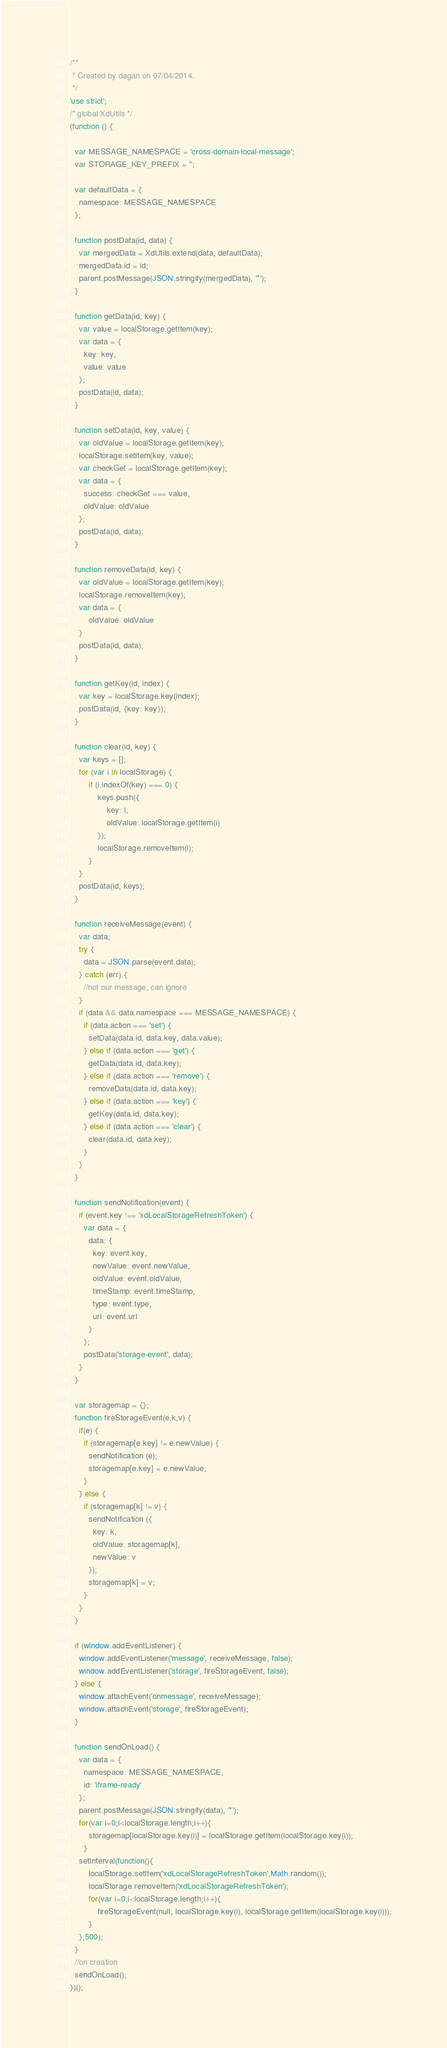<code> <loc_0><loc_0><loc_500><loc_500><_JavaScript_>/**
 * Created by dagan on 07/04/2014.
 */
'use strict';
/* global XdUtils */
(function () {

  var MESSAGE_NAMESPACE = 'cross-domain-local-message';
  var STORAGE_KEY_PREFIX = '';

  var defaultData = {
    namespace: MESSAGE_NAMESPACE
  };

  function postData(id, data) {
    var mergedData = XdUtils.extend(data, defaultData);
    mergedData.id = id;
    parent.postMessage(JSON.stringify(mergedData), '*');
  }

  function getData(id, key) {
    var value = localStorage.getItem(key);
    var data = {
      key: key,
      value: value
    };
    postData(id, data);
  }

  function setData(id, key, value) {
    var oldValue = localStorage.getItem(key);
    localStorage.setItem(key, value);
    var checkGet = localStorage.getItem(key);
    var data = {
      success: checkGet === value,
      oldValue: oldValue
    };
    postData(id, data);
  }

  function removeData(id, key) {
    var oldValue = localStorage.getItem(key);
    localStorage.removeItem(key);
    var data = {
        oldValue: oldValue
    }
    postData(id, data);
  }

  function getKey(id, index) {
    var key = localStorage.key(index);
    postData(id, {key: key});
  }

  function clear(id, key) {
    var keys = [];
    for (var i in localStorage) {
        if (i.indexOf(key) === 0) {
            keys.push({
                key: i,
                oldValue: localStorage.getItem(i)
            });
            localStorage.removeItem(i);
        }
    }
    postData(id, keys);
  }

  function receiveMessage(event) {
    var data;
    try {
      data = JSON.parse(event.data);
    } catch (err) {
      //not our message, can ignore
    }
    if (data && data.namespace === MESSAGE_NAMESPACE) {
      if (data.action === 'set') {
        setData(data.id, data.key, data.value);
      } else if (data.action === 'get') {
        getData(data.id, data.key);
      } else if (data.action === 'remove') {
        removeData(data.id, data.key);
      } else if (data.action === 'key') {
        getKey(data.id, data.key);
      } else if (data.action === 'clear') {
        clear(data.id, data.key);
      }
    }
  }

  function sendNotification(event) {
    if (event.key !== 'xdLocalStorageRefreshToken') {
      var data = {
        data: {
          key: event.key,
          newValue: event.newValue,
          oldValue: event.oldValue,
          timeStamp: event.timeStamp,
          type: event.type,
          url: event.url
        }
      };
      postData('storage-event', data);
    }
  }

  var storagemap = {};
  function fireStorageEvent(e,k,v) {
    if(e) {
      if (storagemap[e.key] != e.newValue) {
        sendNotification (e);
        storagemap[e.key] = e.newValue;
      }
    } else {
      if (storagemap[k] != v) {
        sendNotification ({
          key: k,
          oldValue: storagemap[k],
          newValue: v
        });
        storagemap[k] = v;
      }
    }
  }
  
  if (window.addEventListener) {
    window.addEventListener('message', receiveMessage, false);
    window.addEventListener('storage', fireStorageEvent, false);
  } else {
    window.attachEvent('onmessage', receiveMessage);
    window.attachEvent('storage', fireStorageEvent);
  }

  function sendOnLoad() {
    var data = {
      namespace: MESSAGE_NAMESPACE,
      id: 'iframe-ready'
    };
    parent.postMessage(JSON.stringify(data), '*');
    for(var i=0;i<localStorage.length;i++){
        storagemap[localStorage.key(i)] = localStorage.getItem(localStorage.key(i));
      }
    setInterval(function(){
        localStorage.setItem('xdLocalStorageRefreshToken',Math.random());
        localStorage.removeItem('xdLocalStorageRefreshToken');
        for(var i=0;i<localStorage.length;i++){
            fireStorageEvent(null, localStorage.key(i), localStorage.getItem(localStorage.key(i)));
        }
    },500);
  }
  //on creation
  sendOnLoad();
})();
</code> 